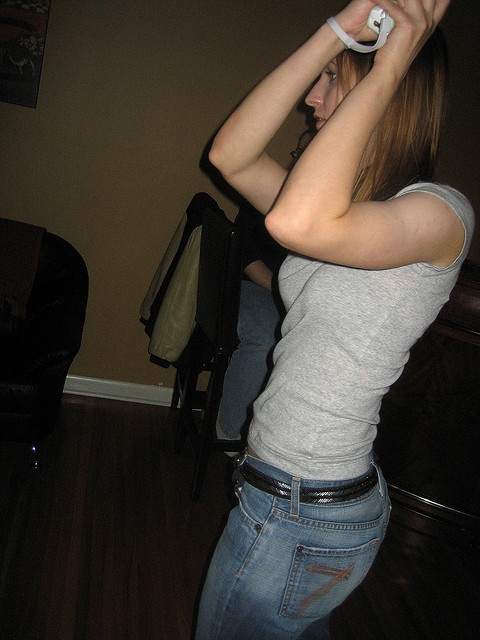Describe the objects in this image and their specific colors. I can see people in black, darkgray, and gray tones, chair in black and darkgreen tones, and remote in black, gray, darkgray, and lightgray tones in this image. 